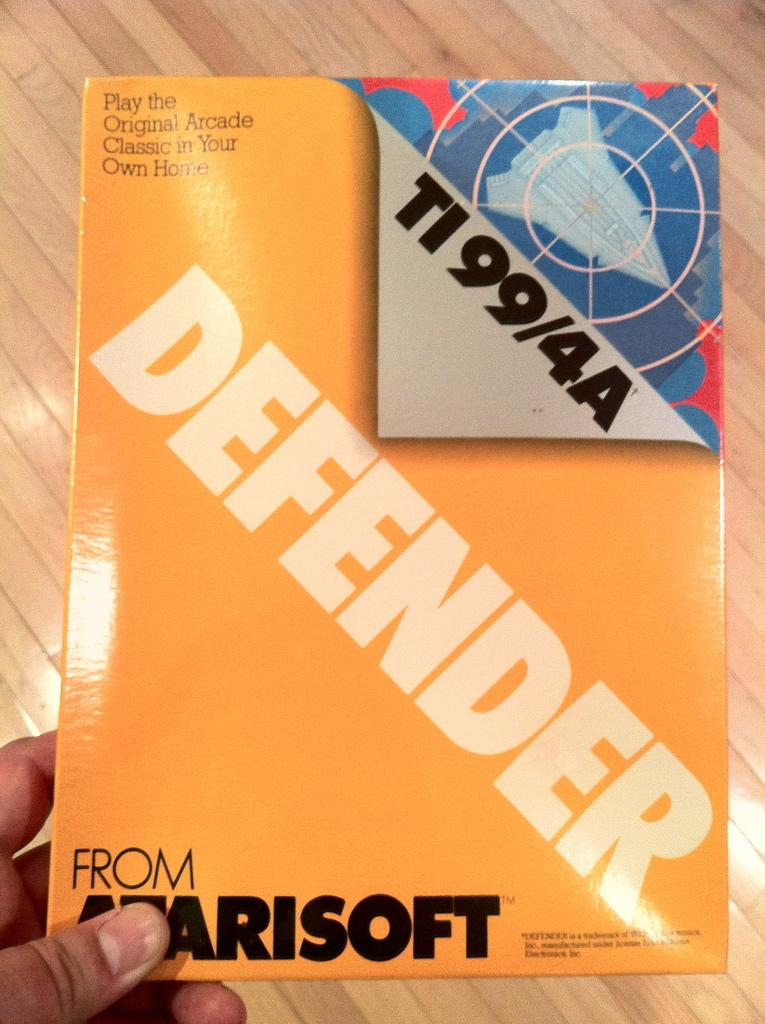Provide a one-sentence caption for the provided image. hand holding yellow box containing defender for ti99/4a. 